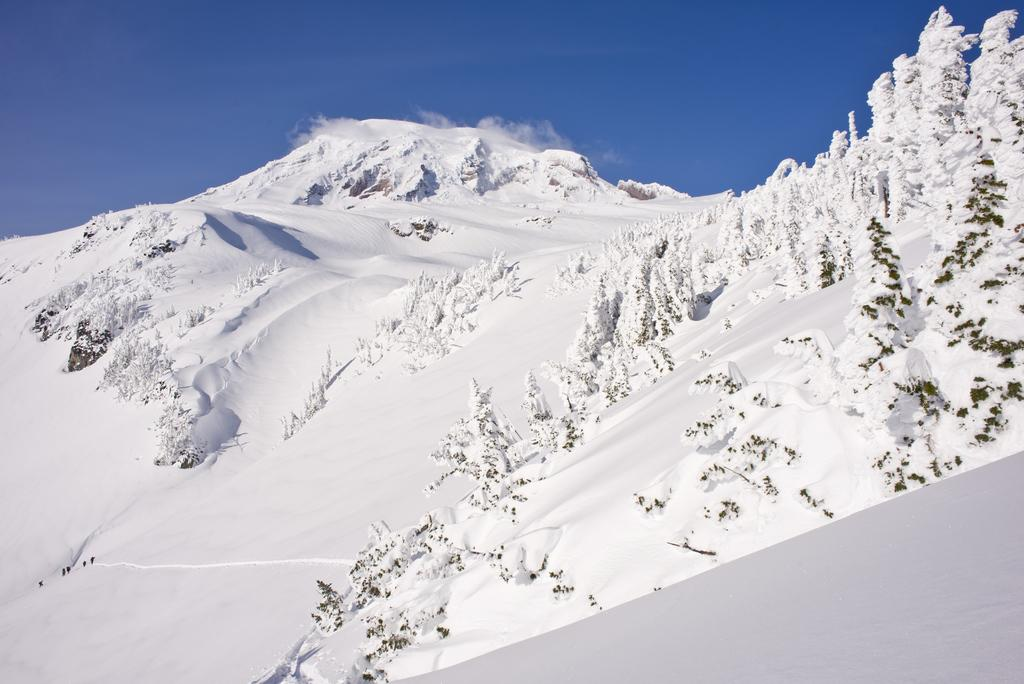What type of natural formation can be seen in the image? There are mountains in the image. What type of vegetation is present in the image? There are trees in the image. How are the trees affected by the weather conditions in the image? The trees are fully covered with snow. What is the condition of the ground in the image? There is snow at the bottom of the image. What is visible at the top of the image? The sky is visible at the top of the image. Can you tell me how many buttons are on the trees in the image? There are no buttons present on the trees in the image; they are fully covered with snow. What type of addition problem can be solved using the mountains in the image? There is no addition problem related to the mountains in the image; it is a photograph of a snowy landscape. 